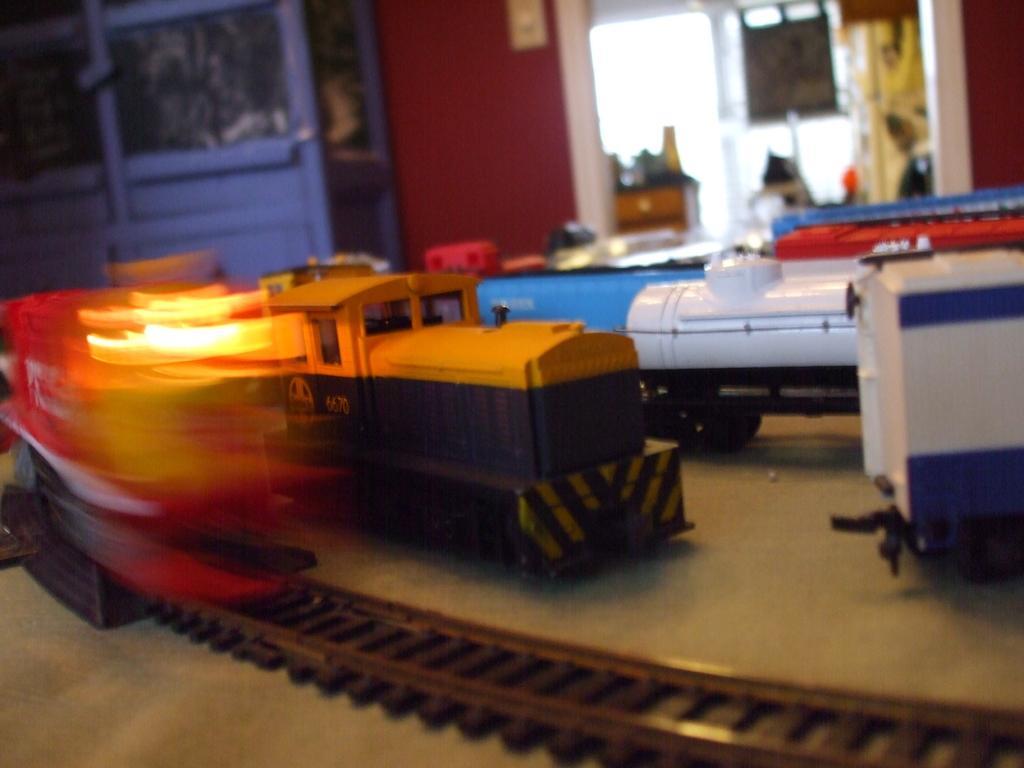Describe this image in one or two sentences. In the center of the image we can see toy train and railway track placed on the table. In the background we can see cupboards, door, window, curtain and wall. 